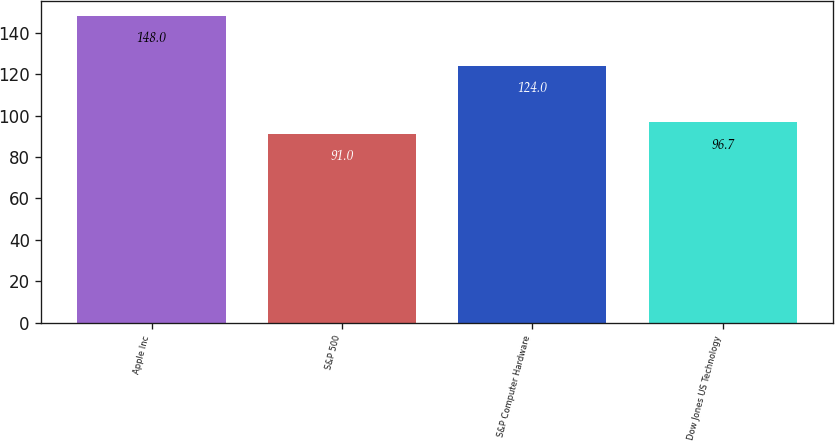<chart> <loc_0><loc_0><loc_500><loc_500><bar_chart><fcel>Apple Inc<fcel>S&P 500<fcel>S&P Computer Hardware<fcel>Dow Jones US Technology<nl><fcel>148<fcel>91<fcel>124<fcel>96.7<nl></chart> 